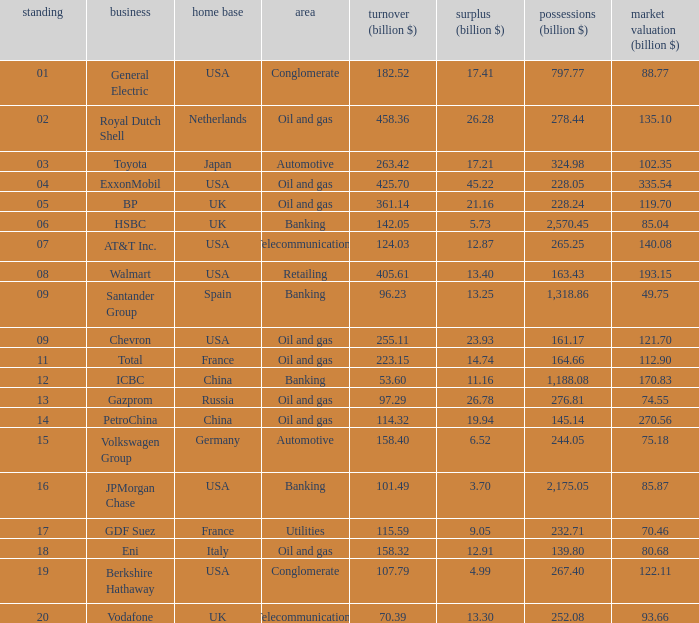Name the Sales (billion $) which have a Company of exxonmobil? 425.7. 